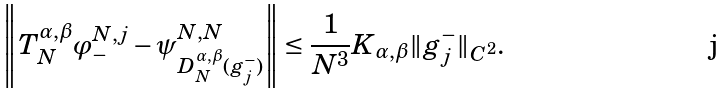<formula> <loc_0><loc_0><loc_500><loc_500>\left \| T ^ { \alpha , \beta } _ { N } \varphi ^ { N , j } _ { - } - \psi ^ { N , N } _ { D ^ { \alpha , \beta } _ { N } ( g ^ { - } _ { j } ) } \right \| \leq \frac { 1 } { N ^ { 3 } } K _ { \alpha , \beta } \| g ^ { - } _ { j } \| _ { C ^ { 2 } } .</formula> 